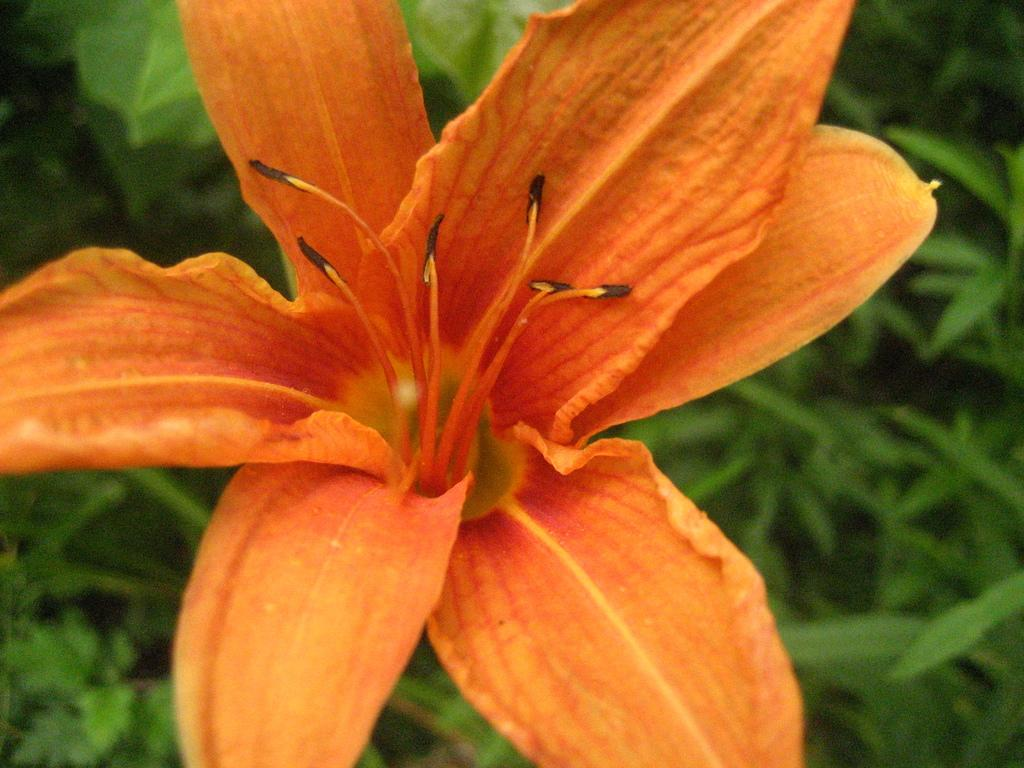What is the main subject in the center of the image? There is a flower in the center of the image. What else can be seen in the image besides the flower? There are plants in the image. What type of juice is being served in the image? There is no juice present in the image; it features a flower and plants. How much debt is visible in the image? There is no debt present in the image; it features a flower and plants. 